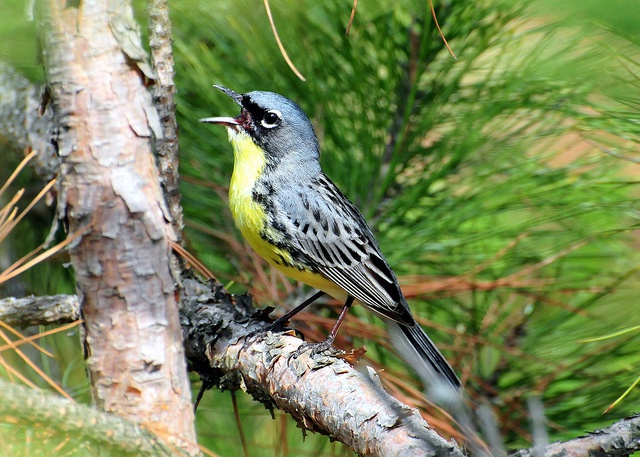Describe the objects in this image and their specific colors. I can see a bird in olive, black, darkgray, gray, and lightgray tones in this image. 